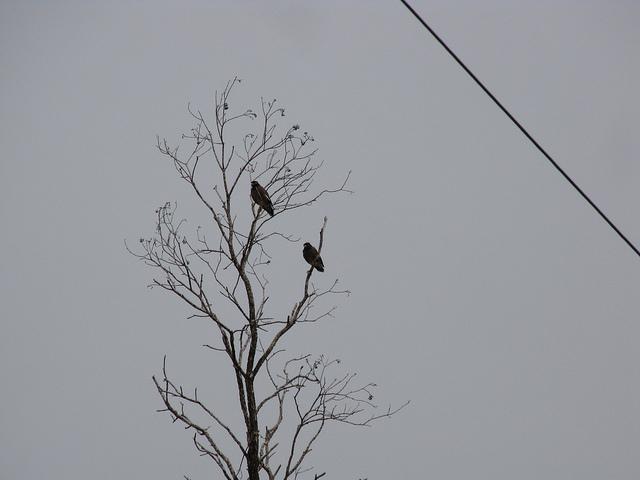How many birds?
Give a very brief answer. 2. How many birds are there?
Give a very brief answer. 2. How many wires are there?
Give a very brief answer. 1. 